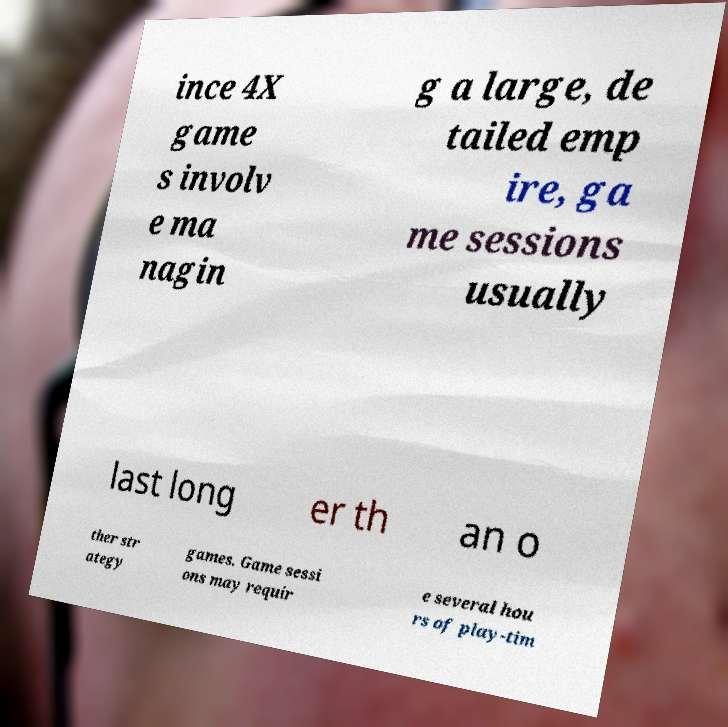For documentation purposes, I need the text within this image transcribed. Could you provide that? ince 4X game s involv e ma nagin g a large, de tailed emp ire, ga me sessions usually last long er th an o ther str ategy games. Game sessi ons may requir e several hou rs of play-tim 